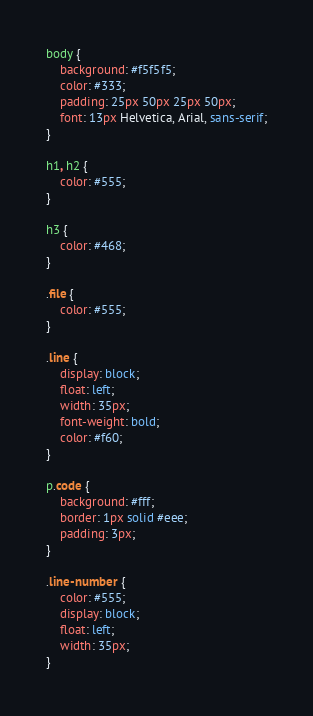Convert code to text. <code><loc_0><loc_0><loc_500><loc_500><_CSS_>body {
	background: #f5f5f5;
	color: #333;
	padding: 25px 50px 25px 50px;
	font: 13px Helvetica, Arial, sans-serif;
}

h1, h2 {
	color: #555;
}

h3 {
	color: #468;
}

.file {
	color: #555;
}

.line {
	display: block;
	float: left;
	width: 35px;
	font-weight: bold;
	color: #f60;
}

p.code {
	background: #fff;
	border: 1px solid #eee;
	padding: 3px;
}

.line-number {
	color: #555;
	display: block;
	float: left;
	width: 35px;
}
</code> 